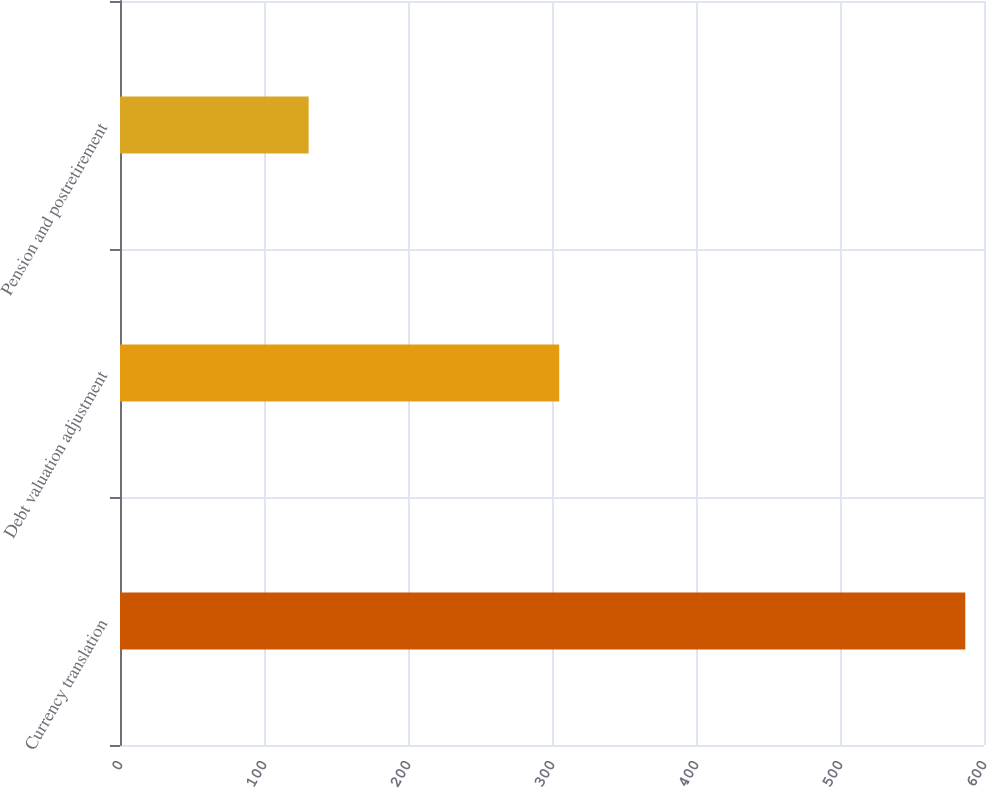Convert chart. <chart><loc_0><loc_0><loc_500><loc_500><bar_chart><fcel>Currency translation<fcel>Debt valuation adjustment<fcel>Pension and postretirement<nl><fcel>587<fcel>305<fcel>131<nl></chart> 